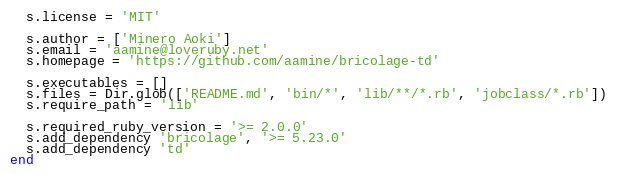Convert code to text. <code><loc_0><loc_0><loc_500><loc_500><_Ruby_>  s.license = 'MIT'

  s.author = ['Minero Aoki']
  s.email = 'aamine@loveruby.net'
  s.homepage = 'https://github.com/aamine/bricolage-td'

  s.executables = []
  s.files = Dir.glob(['README.md', 'bin/*', 'lib/**/*.rb', 'jobclass/*.rb'])
  s.require_path = 'lib'

  s.required_ruby_version = '>= 2.0.0'
  s.add_dependency 'bricolage', '>= 5.23.0'
  s.add_dependency 'td'
end
</code> 